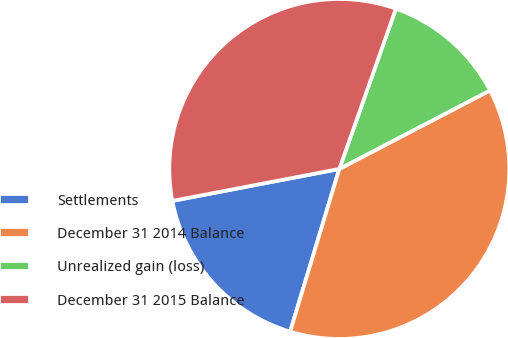Convert chart. <chart><loc_0><loc_0><loc_500><loc_500><pie_chart><fcel>Settlements<fcel>December 31 2014 Balance<fcel>Unrealized gain (loss)<fcel>December 31 2015 Balance<nl><fcel>17.32%<fcel>37.32%<fcel>11.95%<fcel>33.41%<nl></chart> 